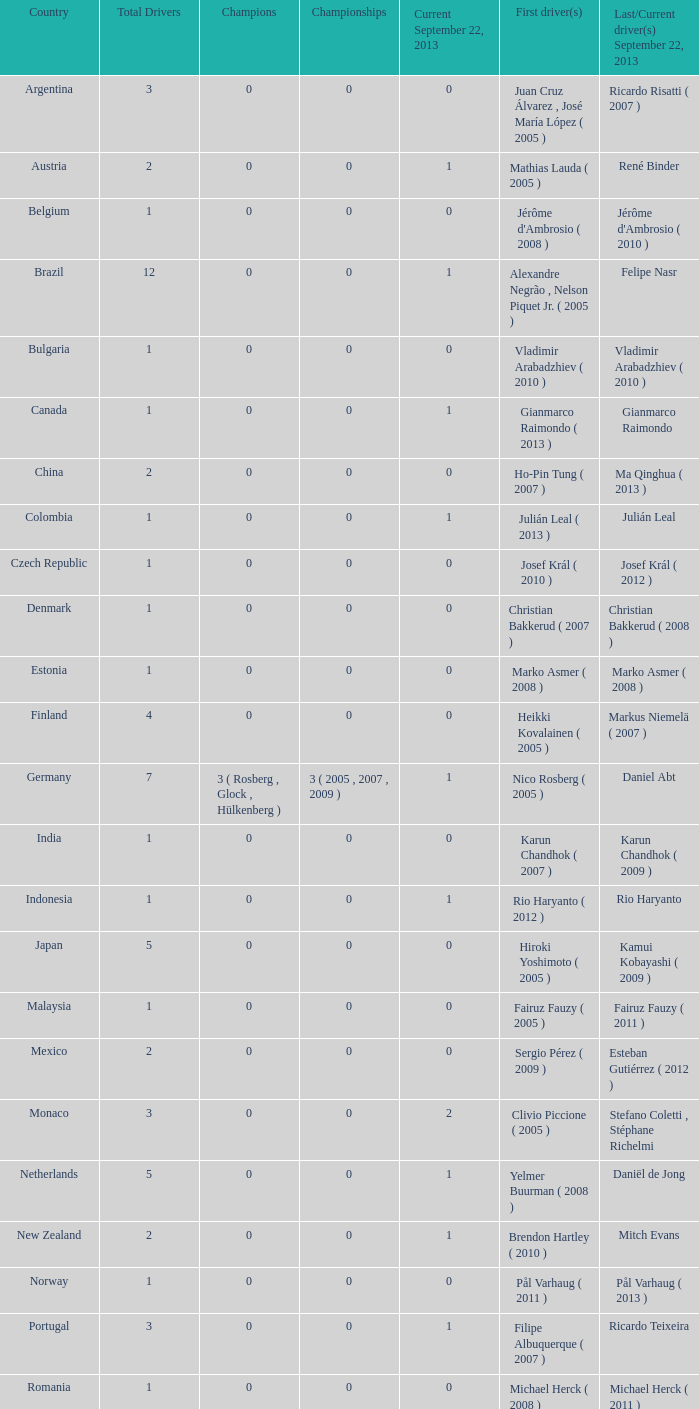How many winners were in existence when the concluding driver for september 22, 2013, was vladimir arabadzhiev (2010)? 0.0. 